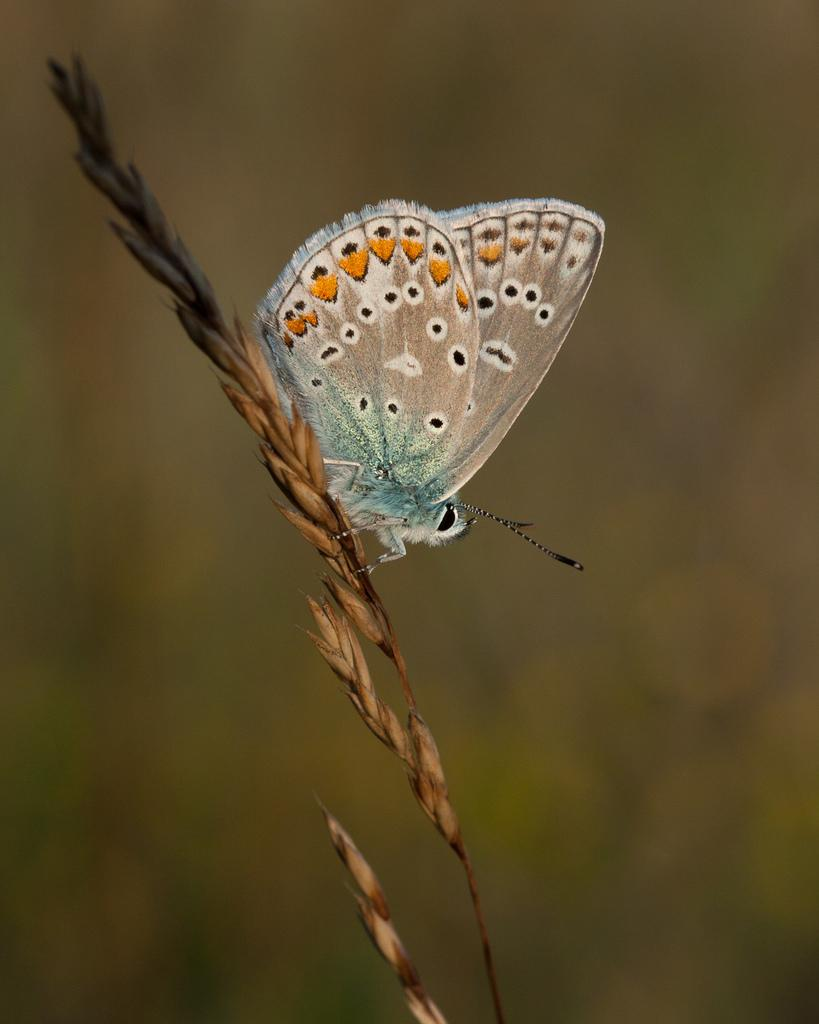What is the straw used for in the image? The straw is used for holding grains in the image. What other element can be seen in the image? There is a butterfly in the image. How would you describe the background of the image? The background of the image is blurred. What type of things are being smashed by the butterfly in the image? There are no things being smashed by the butterfly in the image; the butterfly is simply present in the image. How many balls can be seen in the image? There are no balls present in the image. 